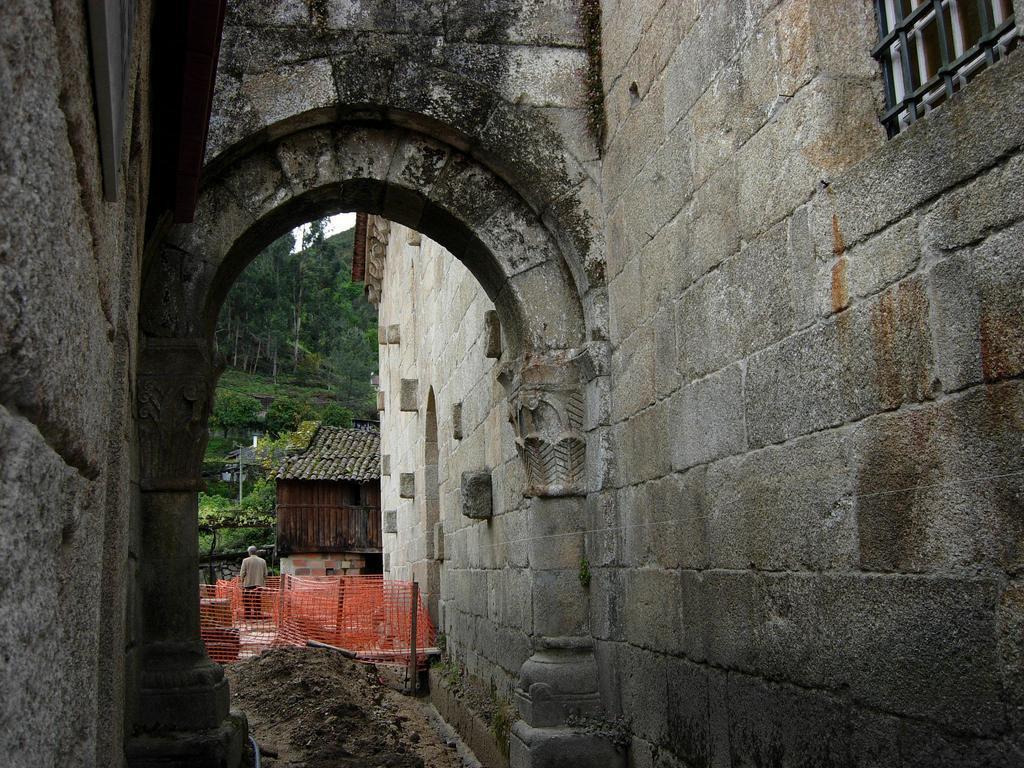Could you give a brief overview of what you see in this image? In this picture we can observe a building. We can observe an entrance here. There is an orange color net. In the background we can observe a house. There are some trees here. 